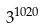Convert formula to latex. <formula><loc_0><loc_0><loc_500><loc_500>3 ^ { 1 0 2 0 }</formula> 